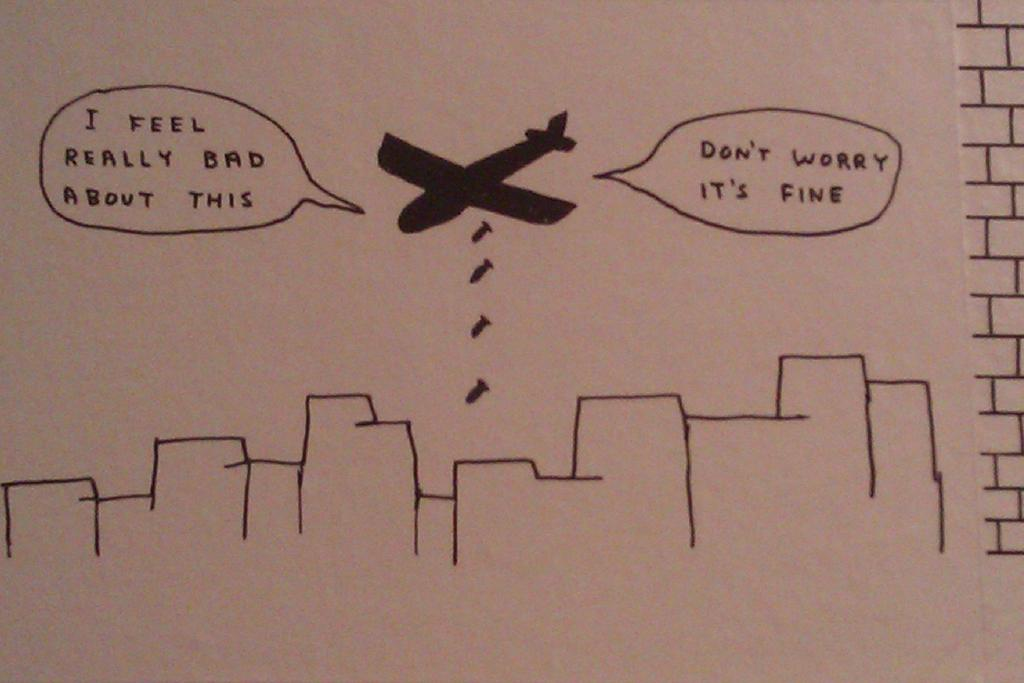What can be found in the image besides the drawing of an airplane? There is text written in the image. Can you describe the drawing in the image? The drawing in the image is of an airplane. What type of paste is being used to hold the airplane drawing in the image? There is no paste present in the image, and the airplane drawing is not being held in place by any adhesive. 